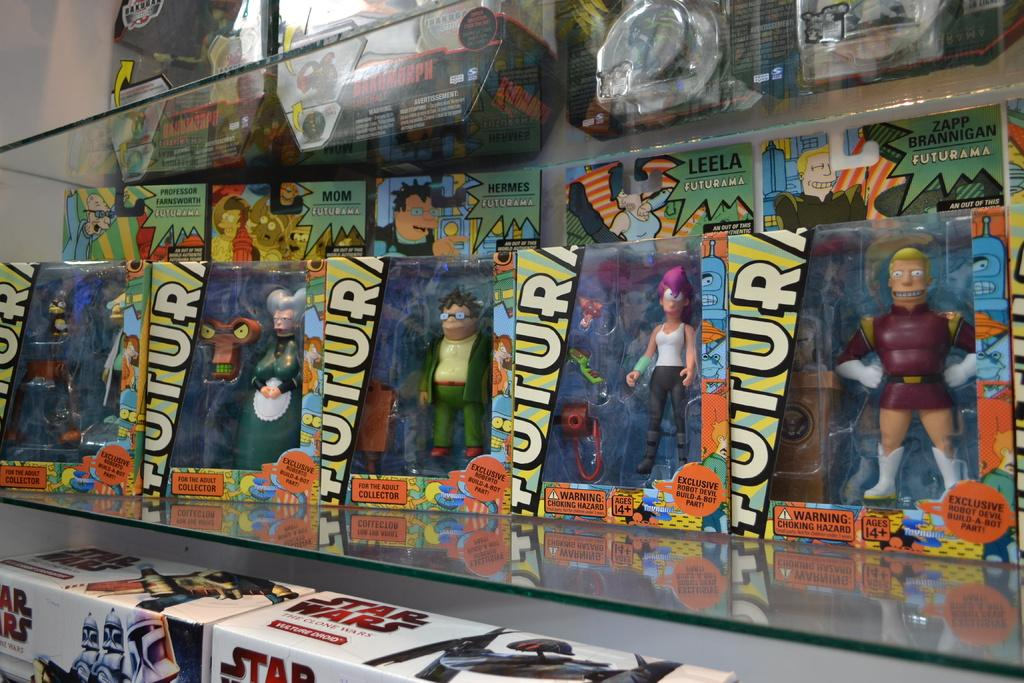<image>
Relay a brief, clear account of the picture shown. Various Futurama dolls are lined up on a shelf above some Star Wars toys. 